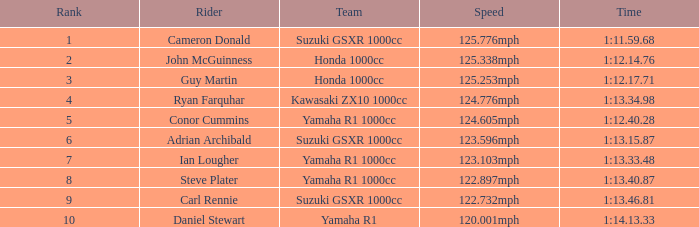What is the position for the team with a time of 1:1 5.0. 